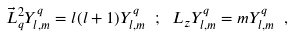<formula> <loc_0><loc_0><loc_500><loc_500>\vec { L } _ { q } ^ { 2 } Y _ { l , m } ^ { q } = l ( l + 1 ) Y _ { l , m } ^ { q } \ ; \ L _ { z } Y _ { l , m } ^ { q } = m Y _ { l , m } ^ { q } \ ,</formula> 